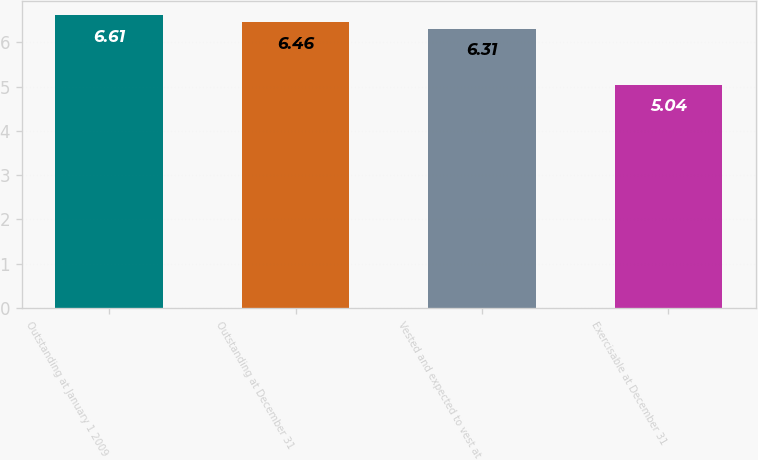<chart> <loc_0><loc_0><loc_500><loc_500><bar_chart><fcel>Outstanding at January 1 2009<fcel>Outstanding at December 31<fcel>Vested and expected to vest at<fcel>Exercisable at December 31<nl><fcel>6.61<fcel>6.46<fcel>6.31<fcel>5.04<nl></chart> 